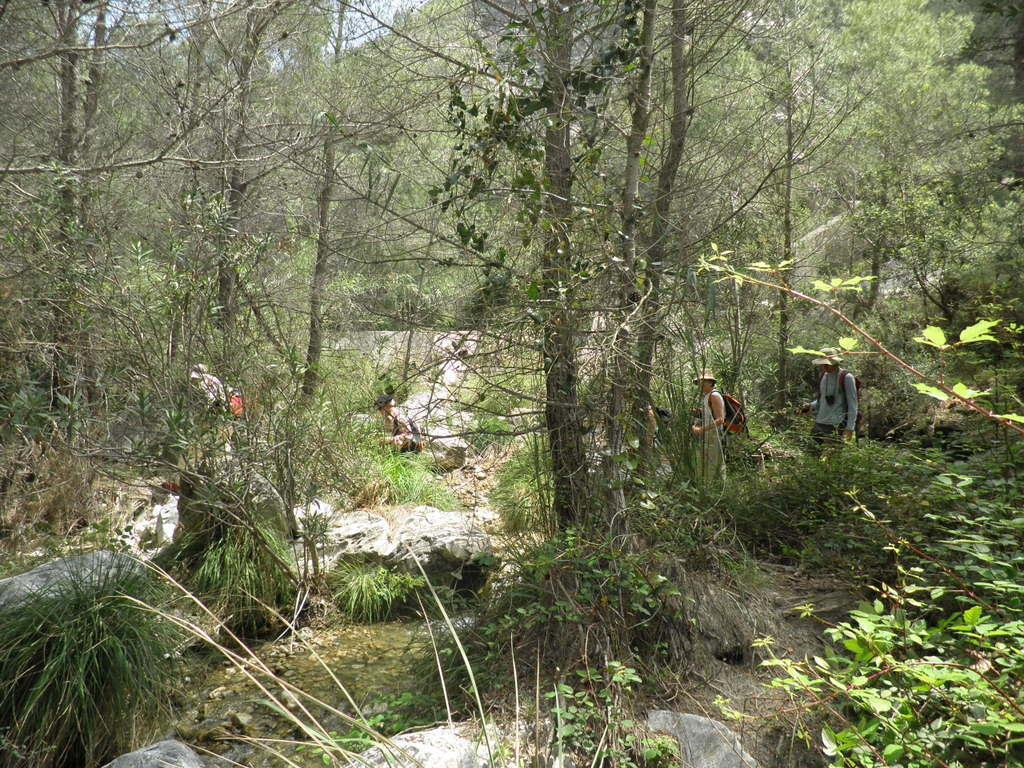What can be seen in the image? There are people and trees in the image. What type of vegetation is present in the image? There are plants in the image. What type of tax is being discussed by the people in the image? There is no indication in the image that the people are discussing any type of tax. 